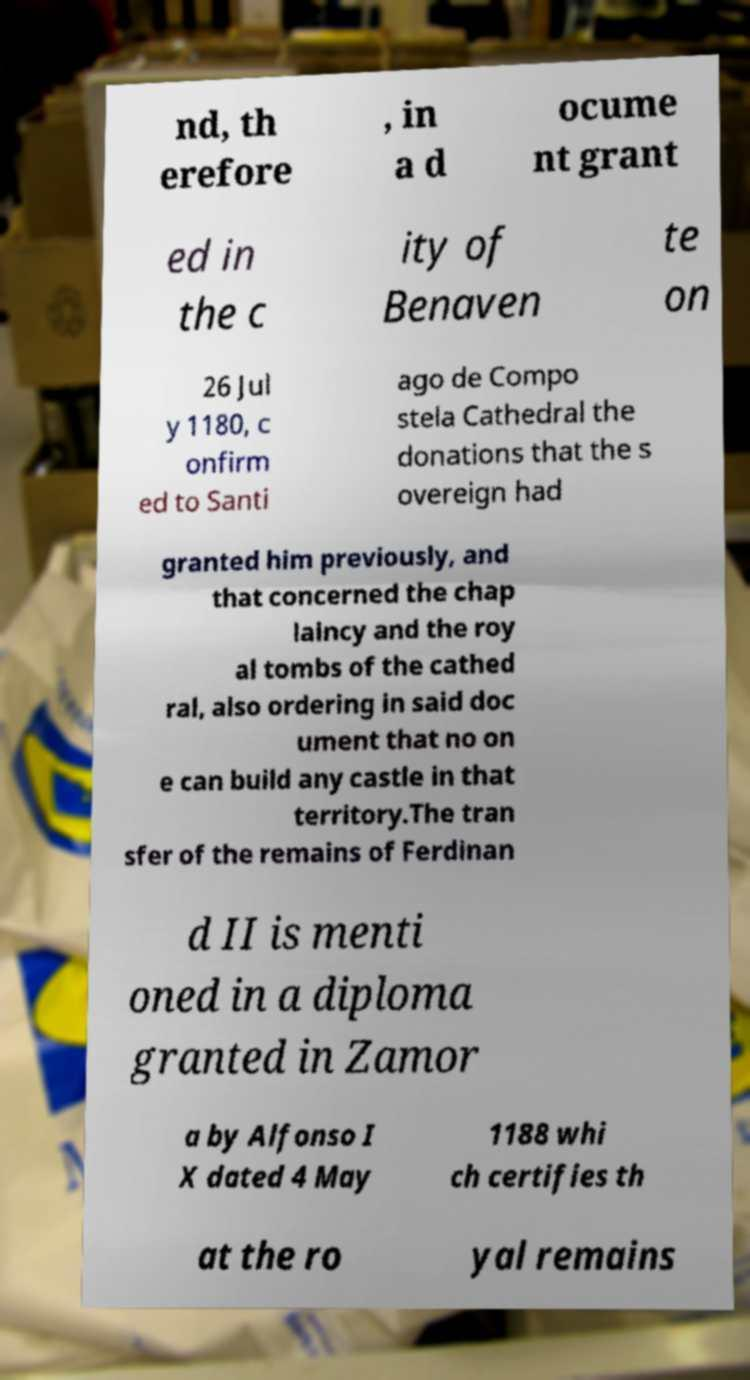I need the written content from this picture converted into text. Can you do that? nd, th erefore , in a d ocume nt grant ed in the c ity of Benaven te on 26 Jul y 1180, c onfirm ed to Santi ago de Compo stela Cathedral the donations that the s overeign had granted him previously, and that concerned the chap laincy and the roy al tombs of the cathed ral, also ordering in said doc ument that no on e can build any castle in that territory.The tran sfer of the remains of Ferdinan d II is menti oned in a diploma granted in Zamor a by Alfonso I X dated 4 May 1188 whi ch certifies th at the ro yal remains 